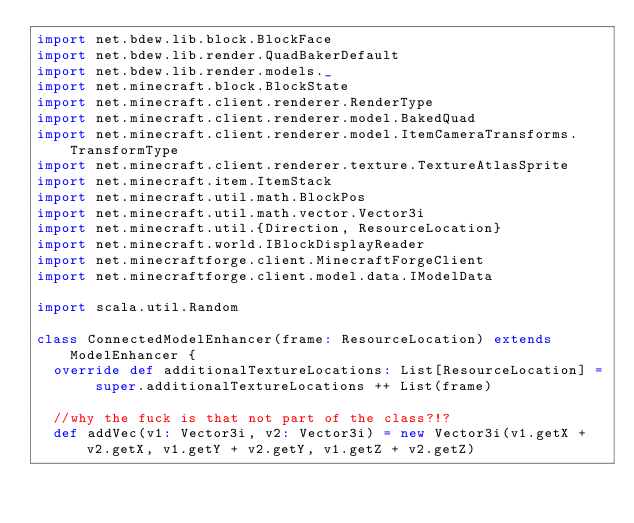<code> <loc_0><loc_0><loc_500><loc_500><_Scala_>import net.bdew.lib.block.BlockFace
import net.bdew.lib.render.QuadBakerDefault
import net.bdew.lib.render.models._
import net.minecraft.block.BlockState
import net.minecraft.client.renderer.RenderType
import net.minecraft.client.renderer.model.BakedQuad
import net.minecraft.client.renderer.model.ItemCameraTransforms.TransformType
import net.minecraft.client.renderer.texture.TextureAtlasSprite
import net.minecraft.item.ItemStack
import net.minecraft.util.math.BlockPos
import net.minecraft.util.math.vector.Vector3i
import net.minecraft.util.{Direction, ResourceLocation}
import net.minecraft.world.IBlockDisplayReader
import net.minecraftforge.client.MinecraftForgeClient
import net.minecraftforge.client.model.data.IModelData

import scala.util.Random

class ConnectedModelEnhancer(frame: ResourceLocation) extends ModelEnhancer {
  override def additionalTextureLocations: List[ResourceLocation] = super.additionalTextureLocations ++ List(frame)

  //why the fuck is that not part of the class?!?
  def addVec(v1: Vector3i, v2: Vector3i) = new Vector3i(v1.getX + v2.getX, v1.getY + v2.getY, v1.getZ + v2.getZ)
</code> 